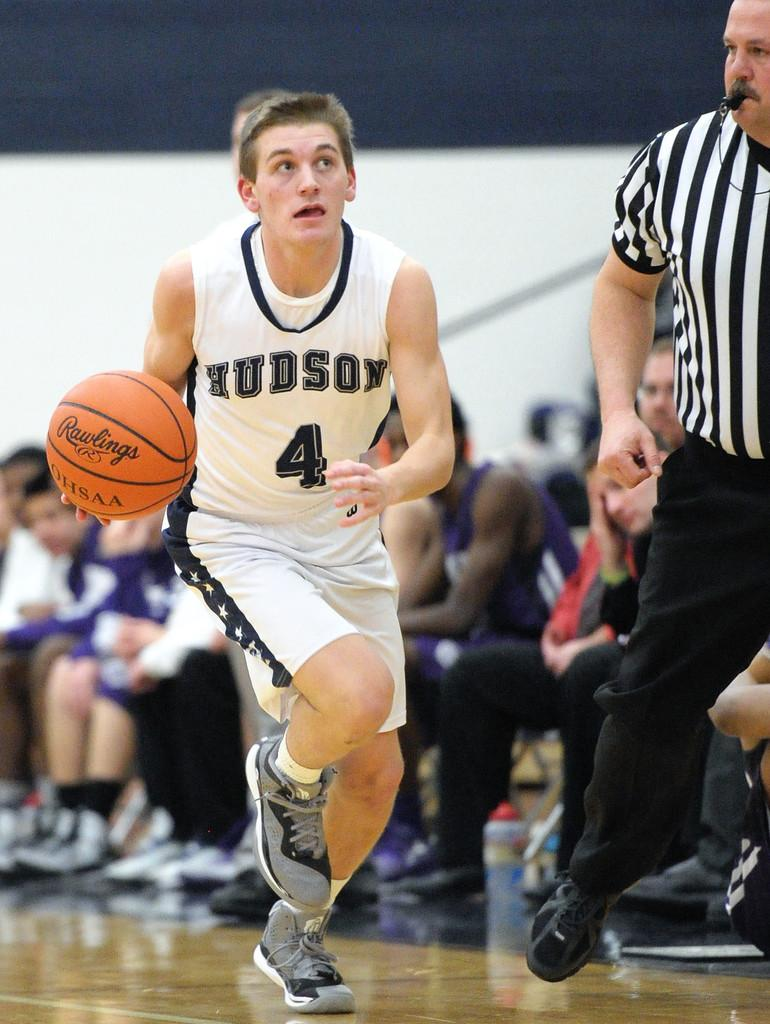<image>
Relay a brief, clear account of the picture shown. A basketball player holding a Rawlings basketball looks up as he runs past the referee. 